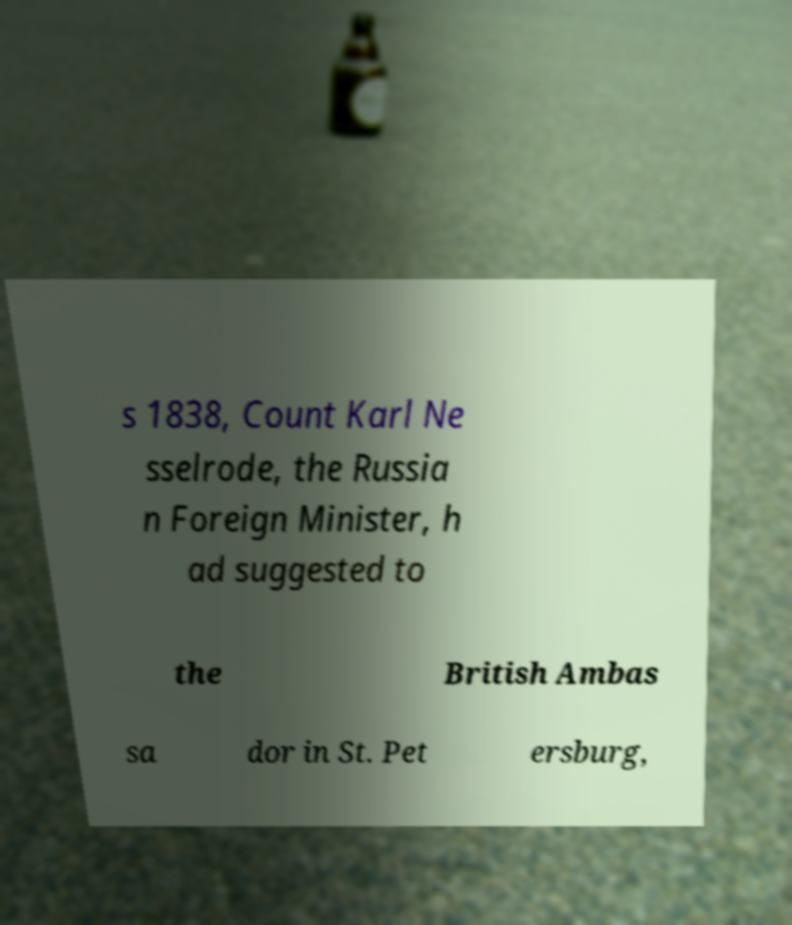Could you extract and type out the text from this image? s 1838, Count Karl Ne sselrode, the Russia n Foreign Minister, h ad suggested to the British Ambas sa dor in St. Pet ersburg, 